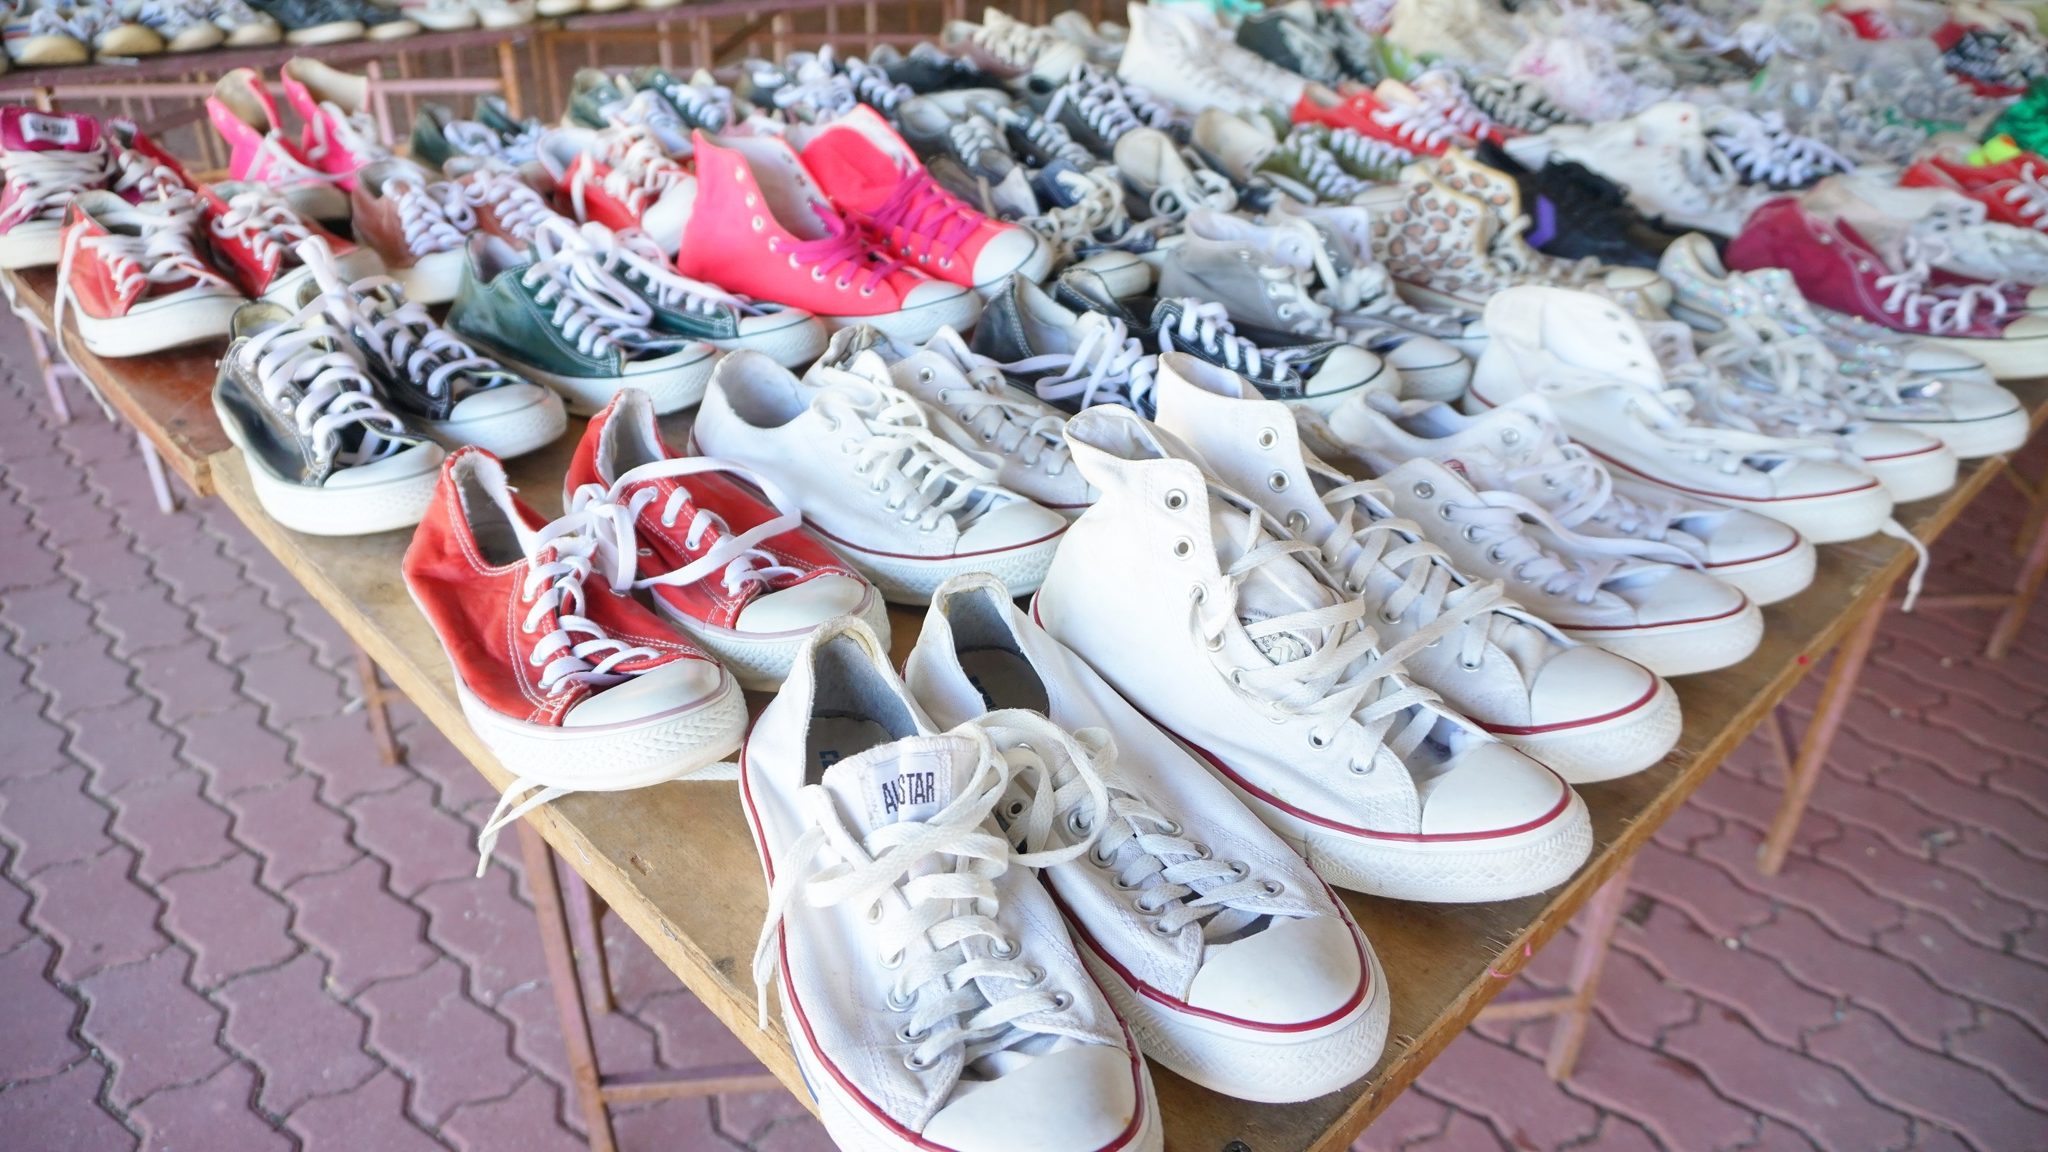What do you think is going on in this snapshot? The image shows a bustling scene at a sneaker sale held on a brick-paved area. A table covered with a white cloth is laden with around 30 pairs of sneakers, prominently featuring Converse All Stars in an array of colors and designs. The sneakers are arranged in an informal and somewhat disorganized manner, suggesting a casual atmosphere. Some sneakers are stacked on top of each other while others are scattered randomly across the table. The vibrant and varied color palette includes reds, whites, grays, with some pairs in pink and blue standing out. This setting exudes a laid-back, outdoor market vibe, where every pair seems to narrate its unique story. 